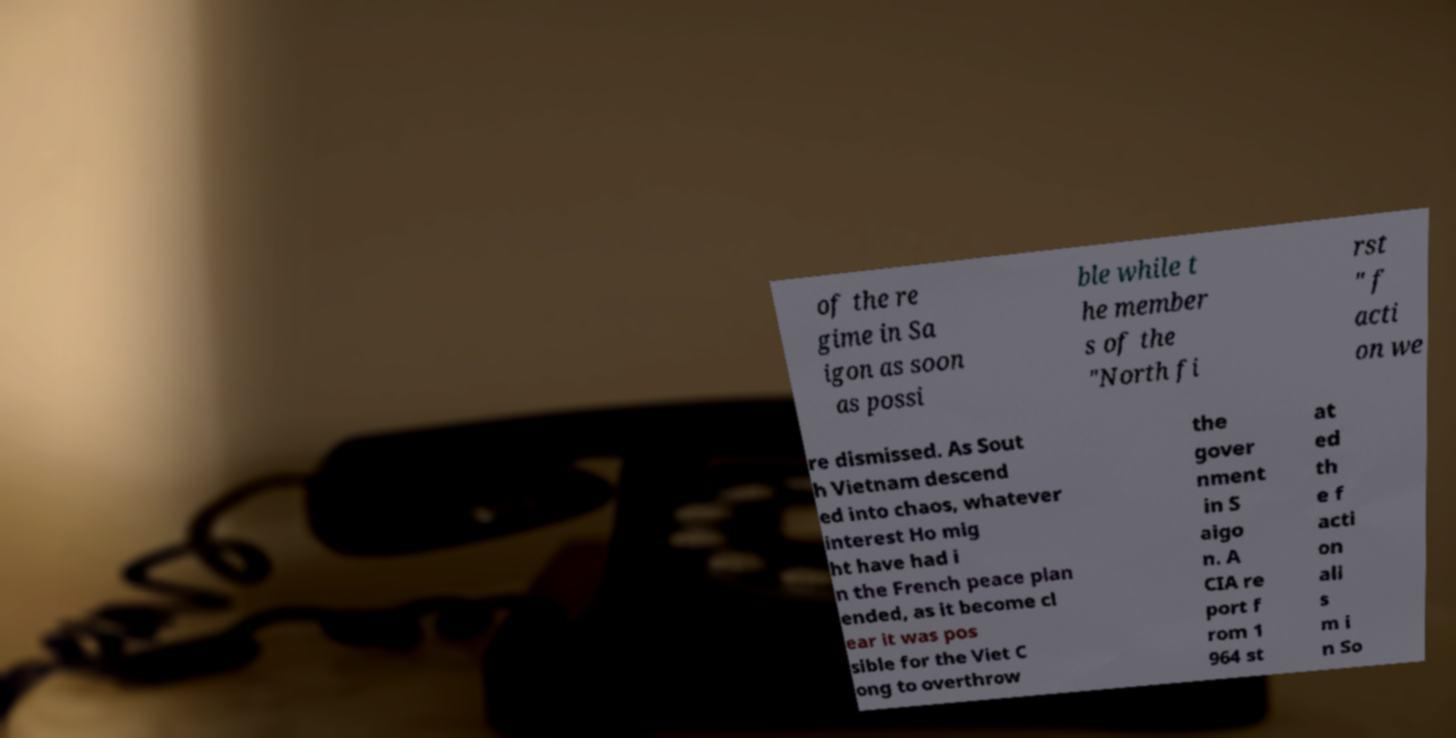What messages or text are displayed in this image? I need them in a readable, typed format. of the re gime in Sa igon as soon as possi ble while t he member s of the "North fi rst " f acti on we re dismissed. As Sout h Vietnam descend ed into chaos, whatever interest Ho mig ht have had i n the French peace plan ended, as it become cl ear it was pos sible for the Viet C ong to overthrow the gover nment in S aigo n. A CIA re port f rom 1 964 st at ed th e f acti on ali s m i n So 